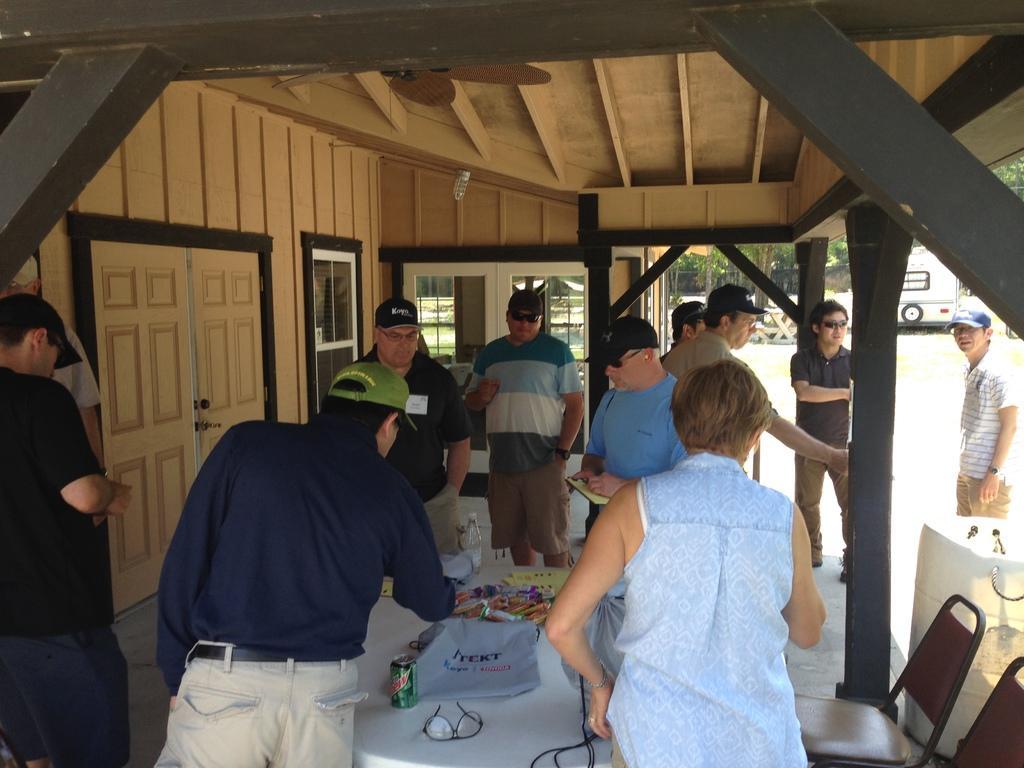Describe this image in one or two sentences. There are few people standing around the table and observing the things on the table. The left side of an image there is a door. The right side of an image there is a vehicle and a person is standing wearing a cap and this last we have trees. 